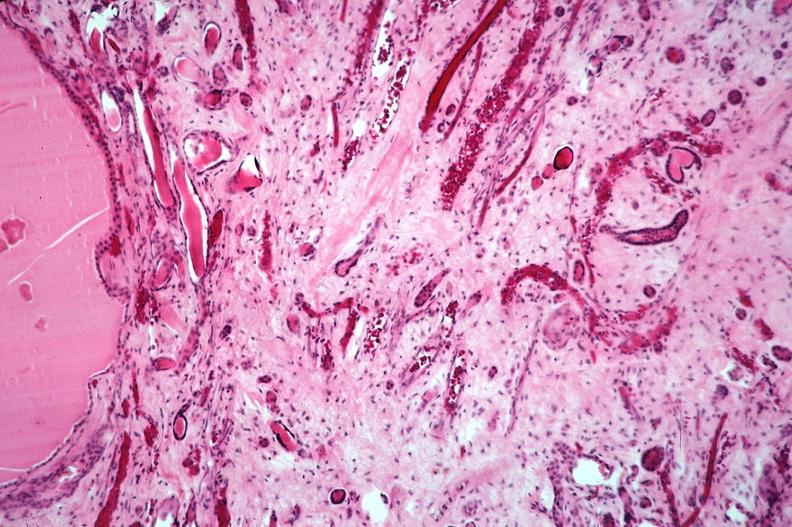does fetus developing very early show kidney, adult polycystic kidney?
Answer the question using a single word or phrase. No 